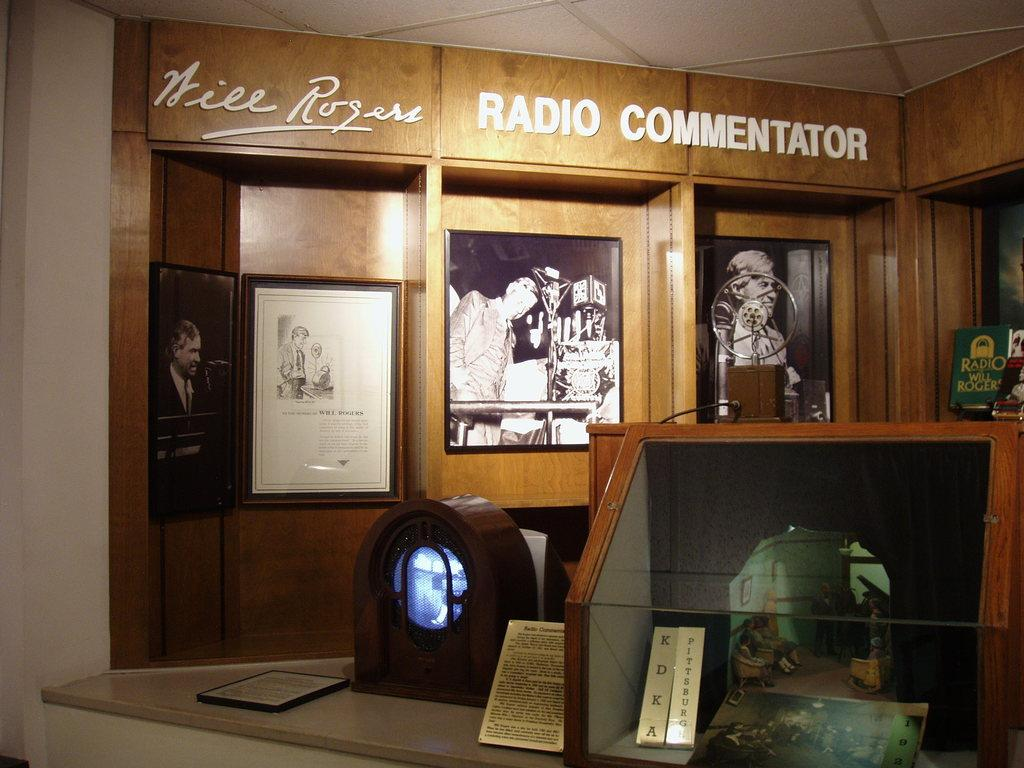<image>
Create a compact narrative representing the image presented. A radio station of the radio commentator Nill Rogers with old pictures of him on the wall. 